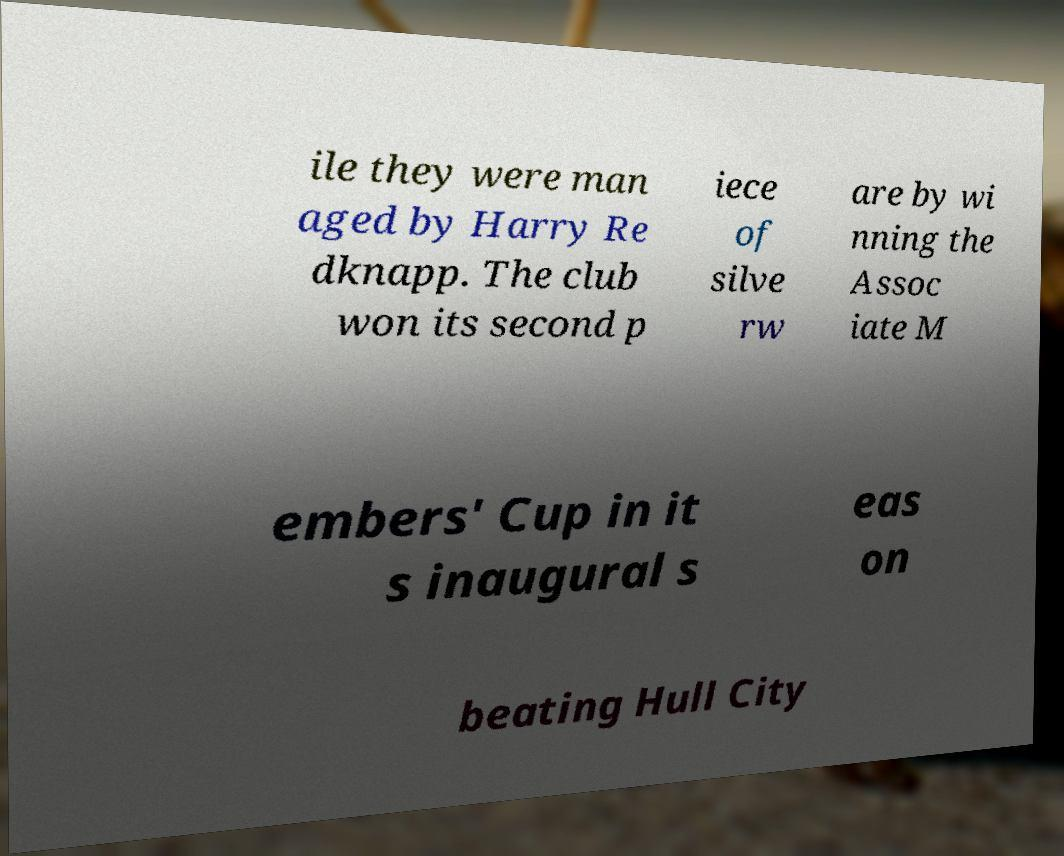There's text embedded in this image that I need extracted. Can you transcribe it verbatim? ile they were man aged by Harry Re dknapp. The club won its second p iece of silve rw are by wi nning the Assoc iate M embers' Cup in it s inaugural s eas on beating Hull City 